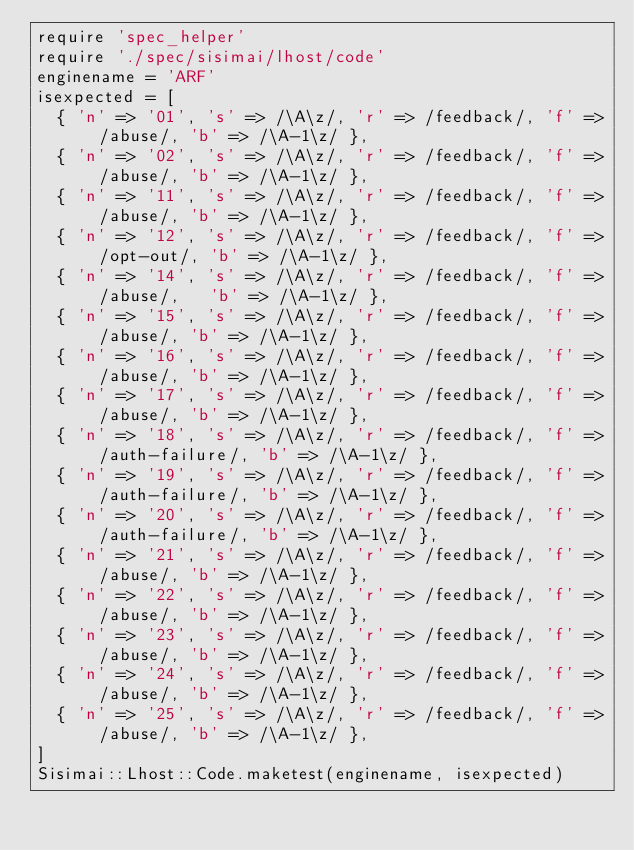<code> <loc_0><loc_0><loc_500><loc_500><_Ruby_>require 'spec_helper'
require './spec/sisimai/lhost/code'
enginename = 'ARF'
isexpected = [
  { 'n' => '01', 's' => /\A\z/, 'r' => /feedback/, 'f' => /abuse/, 'b' => /\A-1\z/ },
  { 'n' => '02', 's' => /\A\z/, 'r' => /feedback/, 'f' => /abuse/, 'b' => /\A-1\z/ },
  { 'n' => '11', 's' => /\A\z/, 'r' => /feedback/, 'f' => /abuse/, 'b' => /\A-1\z/ },
  { 'n' => '12', 's' => /\A\z/, 'r' => /feedback/, 'f' => /opt-out/, 'b' => /\A-1\z/ },
  { 'n' => '14', 's' => /\A\z/, 'r' => /feedback/, 'f' => /abuse/,   'b' => /\A-1\z/ },
  { 'n' => '15', 's' => /\A\z/, 'r' => /feedback/, 'f' => /abuse/, 'b' => /\A-1\z/ },
  { 'n' => '16', 's' => /\A\z/, 'r' => /feedback/, 'f' => /abuse/, 'b' => /\A-1\z/ },
  { 'n' => '17', 's' => /\A\z/, 'r' => /feedback/, 'f' => /abuse/, 'b' => /\A-1\z/ },
  { 'n' => '18', 's' => /\A\z/, 'r' => /feedback/, 'f' => /auth-failure/, 'b' => /\A-1\z/ },
  { 'n' => '19', 's' => /\A\z/, 'r' => /feedback/, 'f' => /auth-failure/, 'b' => /\A-1\z/ },
  { 'n' => '20', 's' => /\A\z/, 'r' => /feedback/, 'f' => /auth-failure/, 'b' => /\A-1\z/ },
  { 'n' => '21', 's' => /\A\z/, 'r' => /feedback/, 'f' => /abuse/, 'b' => /\A-1\z/ },
  { 'n' => '22', 's' => /\A\z/, 'r' => /feedback/, 'f' => /abuse/, 'b' => /\A-1\z/ },
  { 'n' => '23', 's' => /\A\z/, 'r' => /feedback/, 'f' => /abuse/, 'b' => /\A-1\z/ },
  { 'n' => '24', 's' => /\A\z/, 'r' => /feedback/, 'f' => /abuse/, 'b' => /\A-1\z/ },
  { 'n' => '25', 's' => /\A\z/, 'r' => /feedback/, 'f' => /abuse/, 'b' => /\A-1\z/ },
]
Sisimai::Lhost::Code.maketest(enginename, isexpected)

</code> 